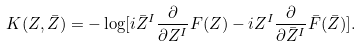Convert formula to latex. <formula><loc_0><loc_0><loc_500><loc_500>K ( Z , \bar { Z } ) = - \log [ i \bar { Z } ^ { I } \frac { \partial } { \partial Z ^ { I } } F ( Z ) - i Z ^ { I } \frac { \partial } { \partial \bar { Z } ^ { I } } \bar { F } ( \bar { Z } ) ] .</formula> 